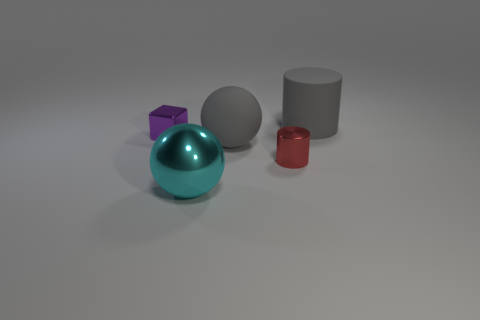How big is the shiny thing that is behind the gray rubber thing that is in front of the big rubber cylinder?
Ensure brevity in your answer.  Small. Do the red thing and the small purple thing have the same shape?
Keep it short and to the point. No. Is there a cyan thing that is in front of the cylinder that is to the right of the tiny cylinder?
Make the answer very short. Yes. Is the size of the cylinder to the right of the red metal thing the same as the large shiny sphere?
Keep it short and to the point. Yes. Is there a matte object that has the same color as the large matte cylinder?
Your answer should be very brief. Yes. How big is the object that is behind the large gray matte ball and right of the big cyan thing?
Make the answer very short. Large. There is a metallic object that is behind the big cyan object and to the right of the tiny purple object; what is its shape?
Your response must be concise. Cylinder. There is a large ball that is the same color as the matte cylinder; what material is it?
Keep it short and to the point. Rubber. The cylinder that is the same color as the matte sphere is what size?
Provide a succinct answer. Large. Is the number of big gray spheres that are to the left of the small purple object less than the number of red metal cubes?
Offer a terse response. No. 